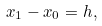<formula> <loc_0><loc_0><loc_500><loc_500>x _ { 1 } - x _ { 0 } = h ,</formula> 